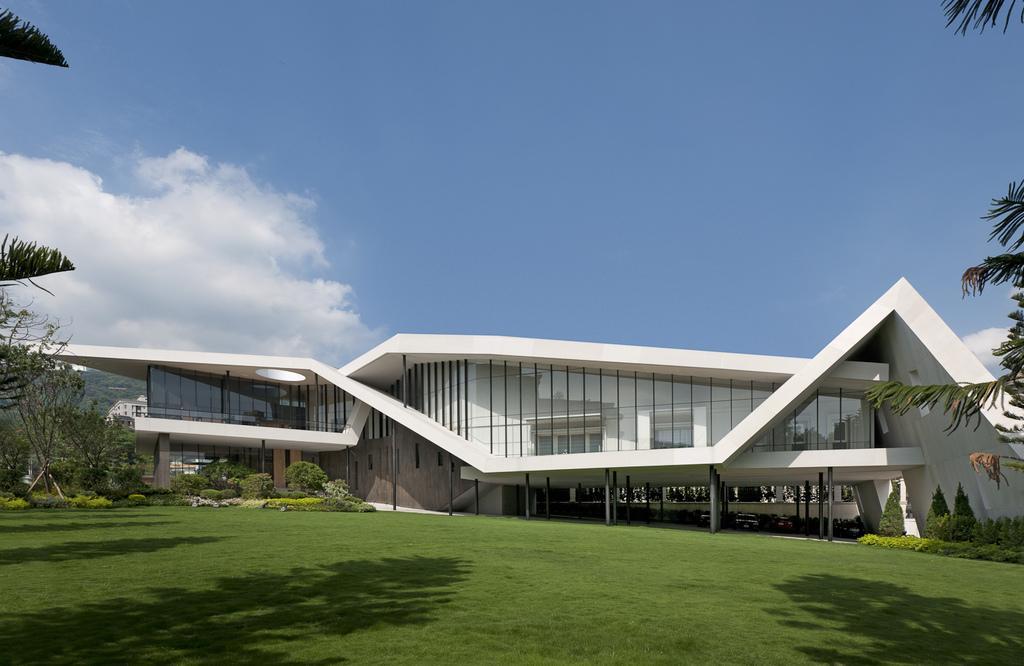Please provide a concise description of this image. In this image there is a garden in the left side there are trees, in the background there is a building and a blue sky. 